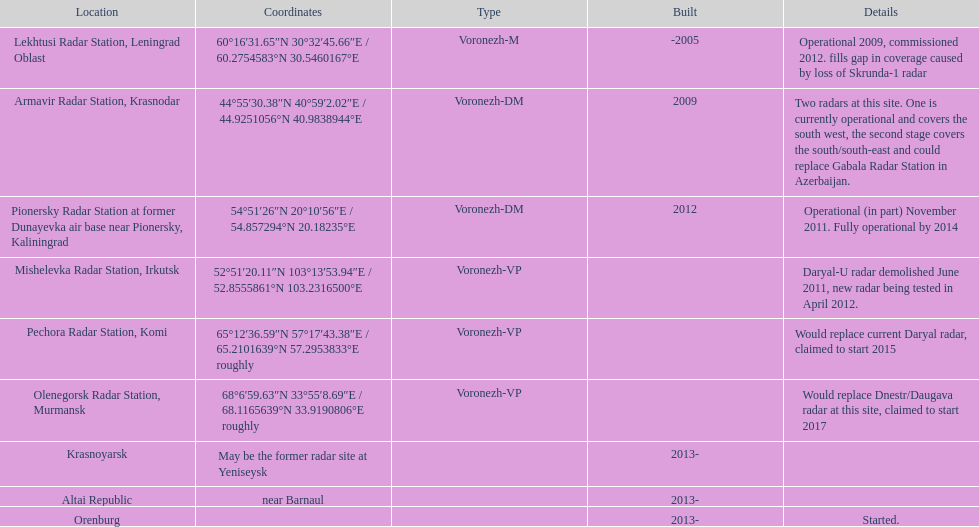What are the radar position registers? Lekhtusi Radar Station, Leningrad Oblast, Armavir Radar Station, Krasnodar, Pionersky Radar Station at former Dunayevka air base near Pionersky, Kaliningrad, Mishelevka Radar Station, Irkutsk, Pechora Radar Station, Komi, Olenegorsk Radar Station, Murmansk, Krasnoyarsk, Altai Republic, Orenburg. Which of them are reported to commence in 2015? Pechora Radar Station, Komi. 